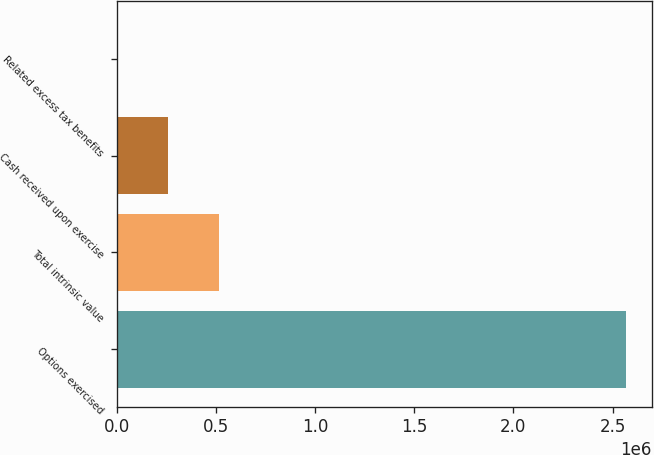<chart> <loc_0><loc_0><loc_500><loc_500><bar_chart><fcel>Options exercised<fcel>Total intrinsic value<fcel>Cash received upon exercise<fcel>Related excess tax benefits<nl><fcel>2.57009e+06<fcel>514042<fcel>257037<fcel>31<nl></chart> 